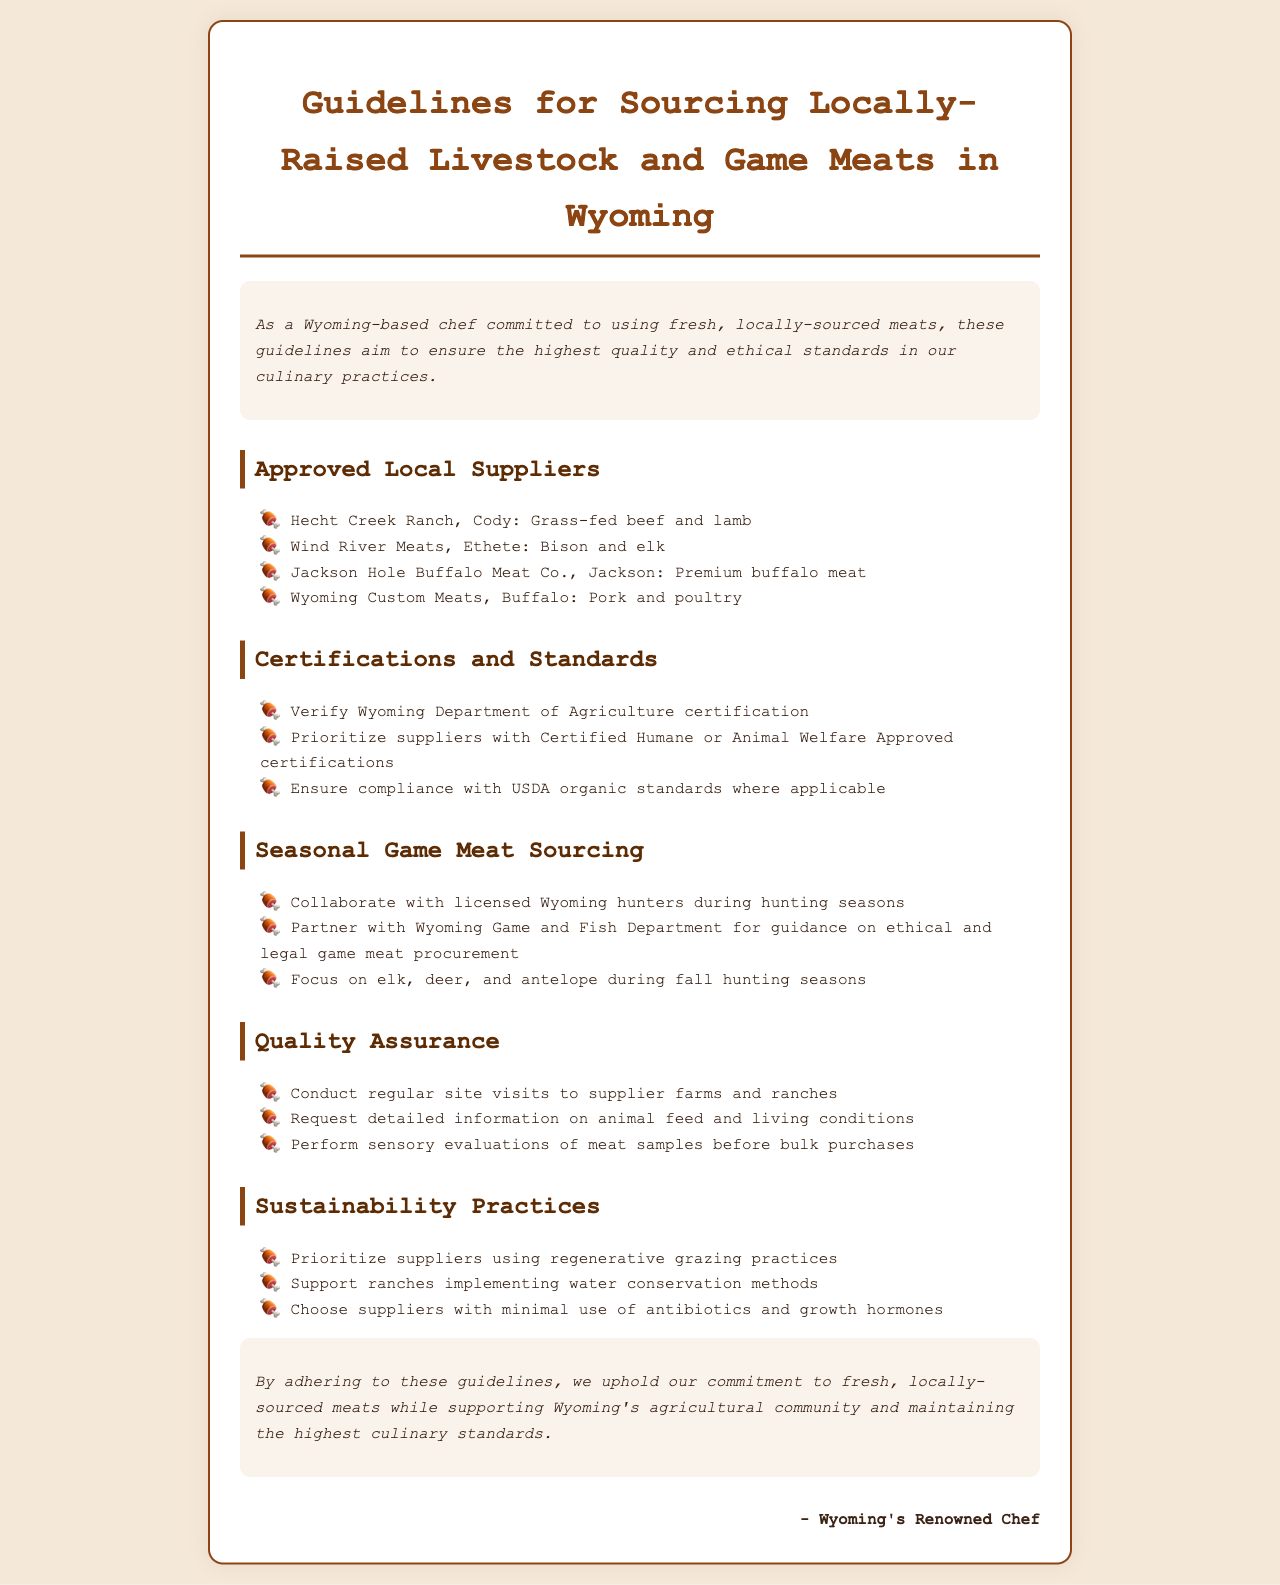What are the approved local suppliers? This question addresses the section detailing the local suppliers recognized for their quality livestock and game meats in Wyoming.
Answer: Hecht Creek Ranch, Wind River Meats, Jackson Hole Buffalo Meat Co., Wyoming Custom Meats Which certifications should be prioritized? This question refers to the required certifications and standards mentioned in the document for ensuring ethical sourcing.
Answer: Certified Humane or Animal Welfare Approved What is the focus during fall hunting seasons? This question pertains to the specific types of game meat that should be sourced during fall hunting seasons, as outlined in the document.
Answer: elk, deer, and antelope How often should site visits be conducted? This question explores the guideline concerning quality assurance practices for supplier farms and ranches.
Answer: regular What sustainability practice is encouraged? This question seeks to identify one of the sustainability measures highlighted in the document regarding meat sourcing.
Answer: regenerative grazing practices Which department should licensed hunters collaborate with? This question inquires about the partnerships suggested for ethical and legal game meat procurement in Wyoming.
Answer: Wyoming Game and Fish Department 